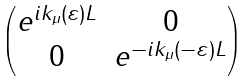<formula> <loc_0><loc_0><loc_500><loc_500>\begin{pmatrix} e ^ { i k _ { \mu } ( \varepsilon ) L } & 0 \\ 0 & e ^ { - i k _ { \mu } ( - \varepsilon ) L } \end{pmatrix}</formula> 